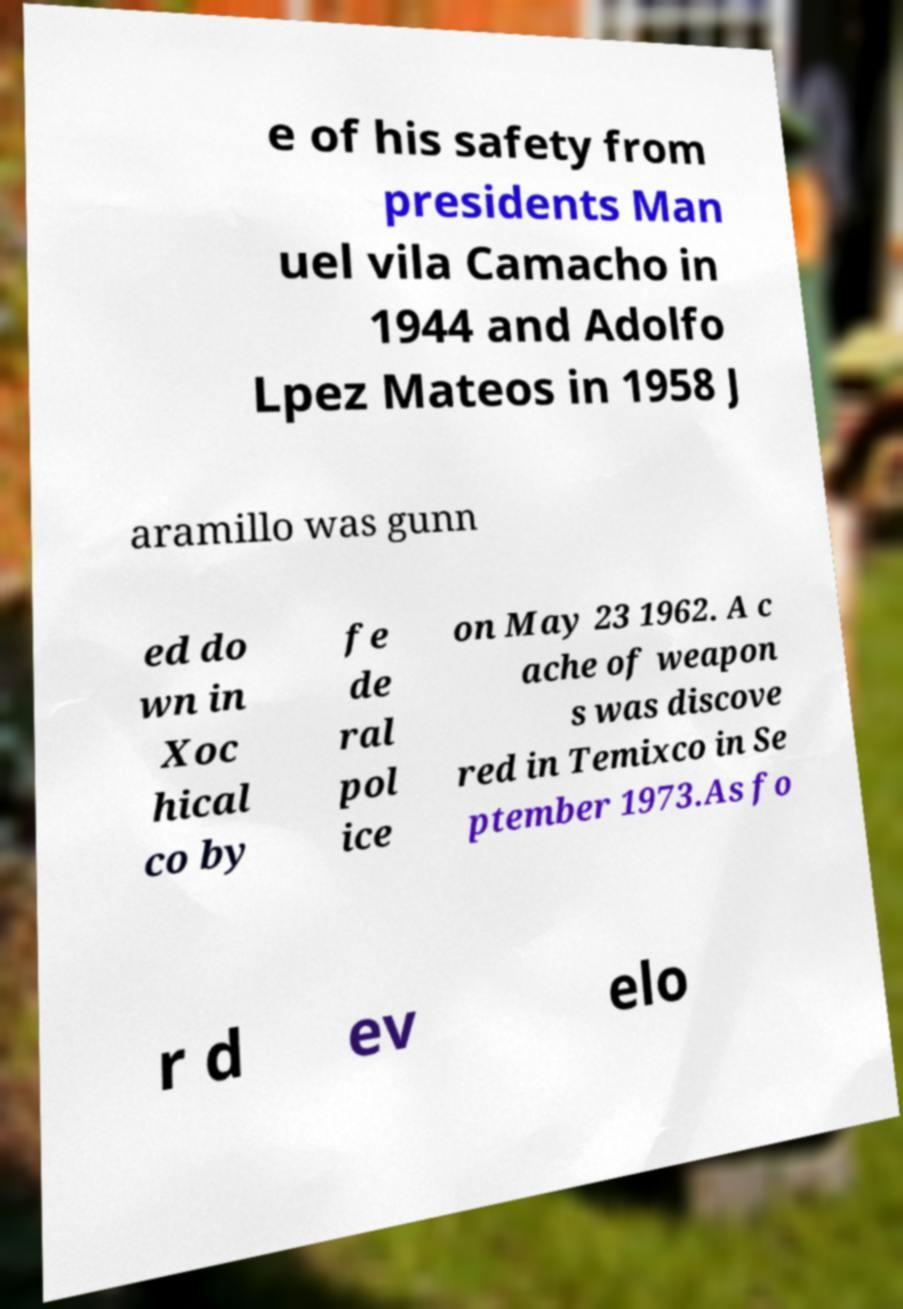Please read and relay the text visible in this image. What does it say? e of his safety from presidents Man uel vila Camacho in 1944 and Adolfo Lpez Mateos in 1958 J aramillo was gunn ed do wn in Xoc hical co by fe de ral pol ice on May 23 1962. A c ache of weapon s was discove red in Temixco in Se ptember 1973.As fo r d ev elo 